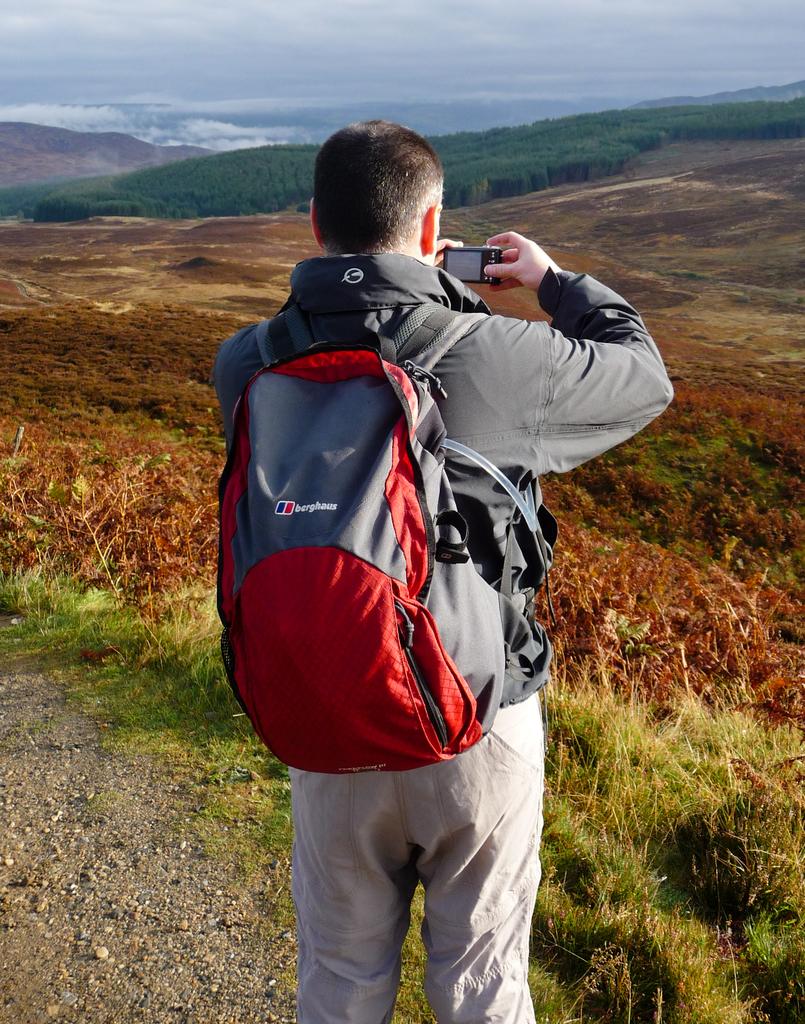What is the brand name on this backpack?
Offer a very short reply. Berghaus. 